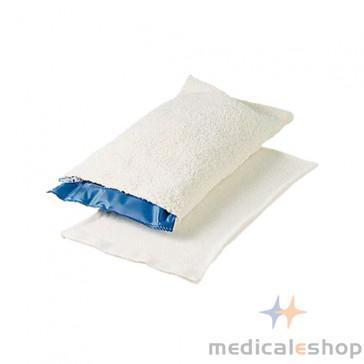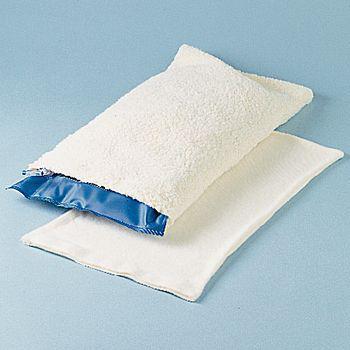The first image is the image on the left, the second image is the image on the right. Analyze the images presented: Is the assertion "The left image contains a single item." valid? Answer yes or no. No. 